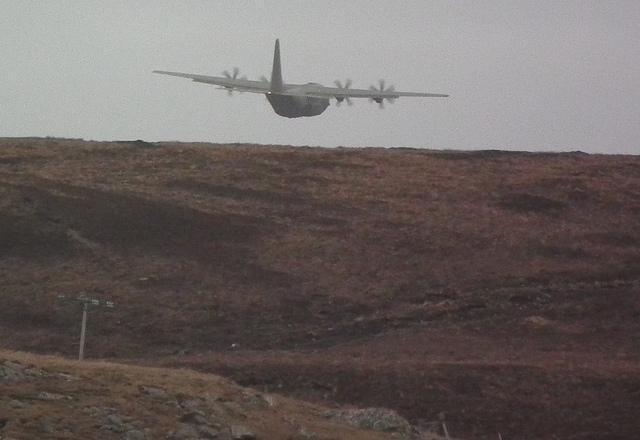How many planes are depicted?
Give a very brief answer. 1. 